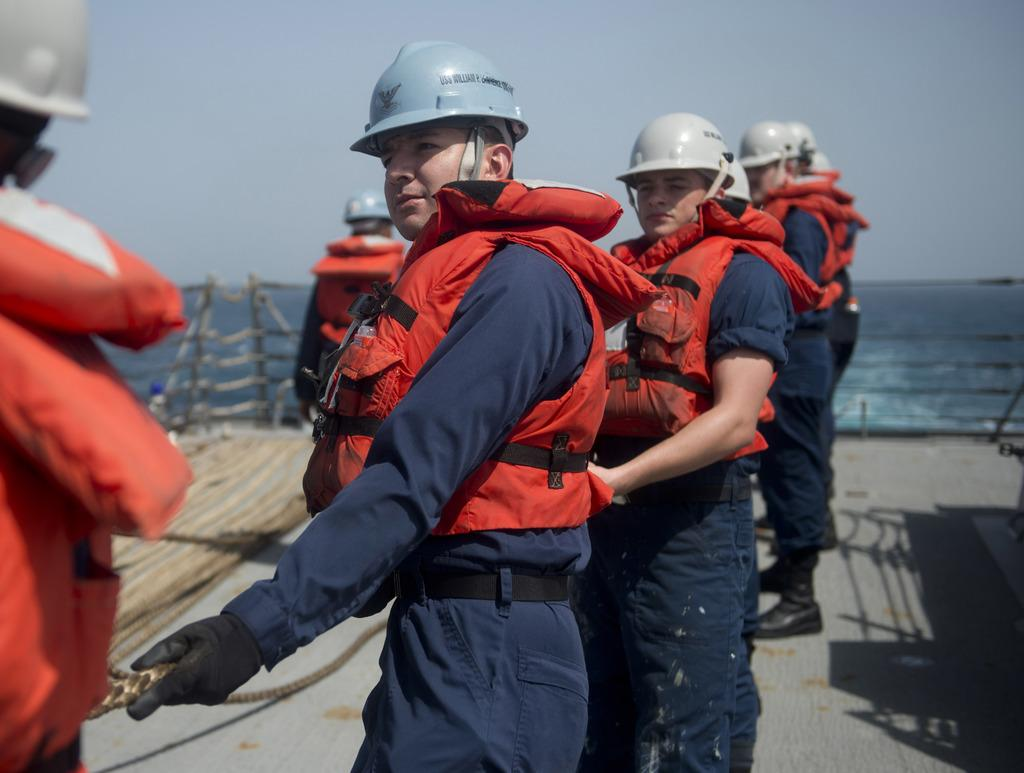What protective gear are the people in the image wearing? The people in the image are wearing life jackets and helmets. What is the man in the image holding? The man in the image is holding a rope. What can be seen in the background of the image? There is a fence, water, and the sky visible in the background of the image. What type of reaction does the squirrel have when it sees the people in the image? There is no squirrel present in the image, so it is not possible to determine its reaction. 